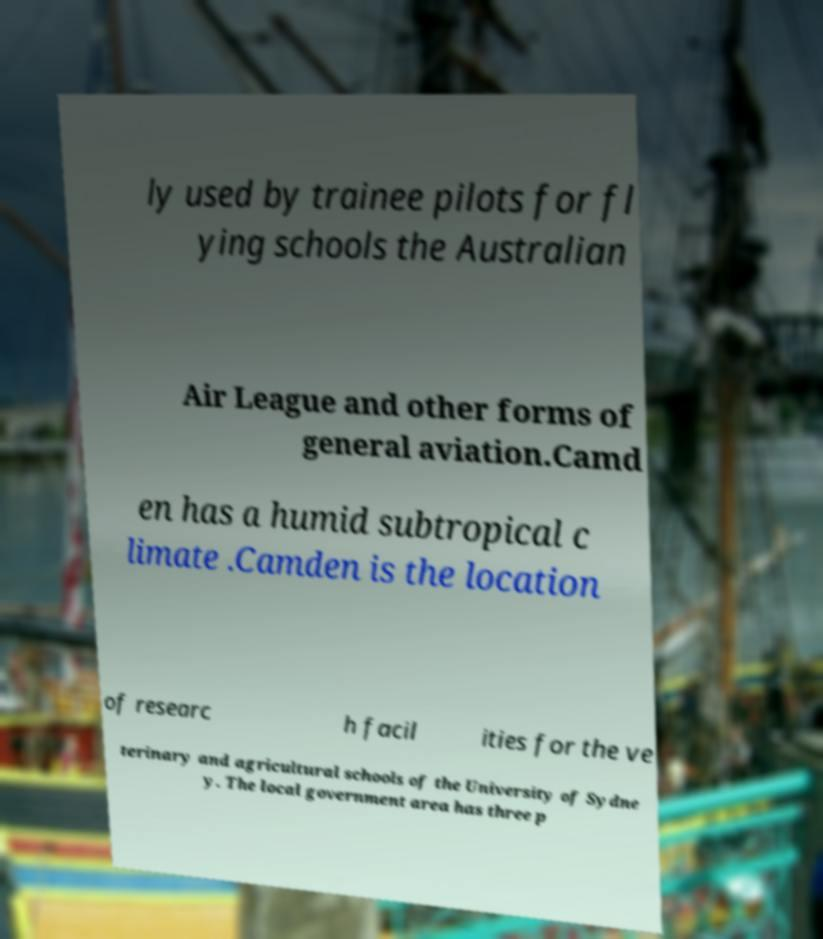Could you extract and type out the text from this image? ly used by trainee pilots for fl ying schools the Australian Air League and other forms of general aviation.Camd en has a humid subtropical c limate .Camden is the location of researc h facil ities for the ve terinary and agricultural schools of the University of Sydne y. The local government area has three p 